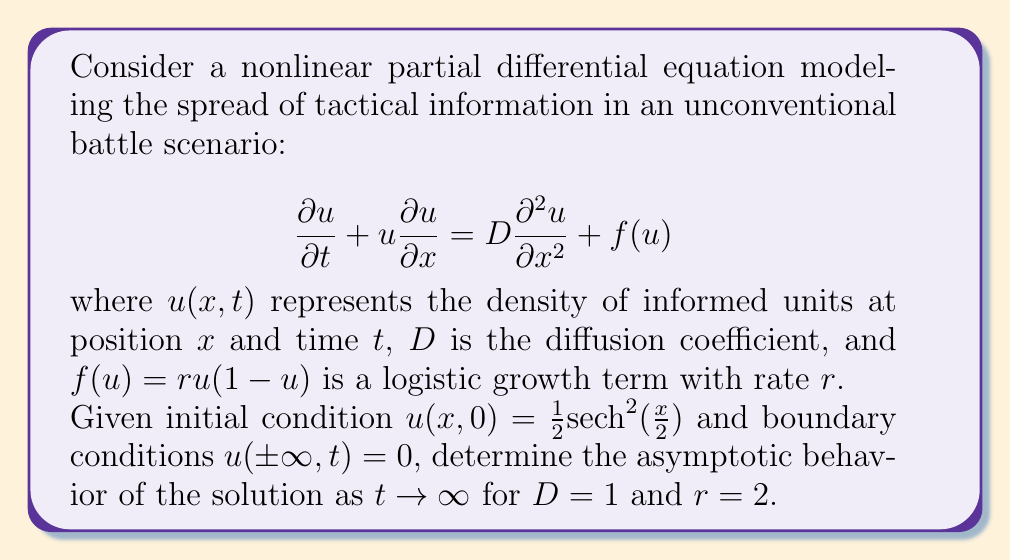Teach me how to tackle this problem. To analyze the asymptotic behavior of this nonlinear PDE, we follow these steps:

1) First, recognize that this equation is a combination of the Burgers' equation and the Fisher-KPP equation.

2) The initial condition $u(x,0) = \frac{1}{2}\text{sech}^2(\frac{x}{2})$ is a localized disturbance that decays to zero as $x \to \pm\infty$.

3) For the Fisher-KPP part ($D\frac{\partial^2 u}{\partial x^2} + ru(1-u)$), we know that:
   - There exist traveling wave solutions.
   - The minimum wave speed is $c_{min} = 2\sqrt{rD} = 2\sqrt{2} \approx 2.83$ for our parameters.

4) The Burgers' part ($u\frac{\partial u}{\partial x}$) introduces nonlinear advection, which can lead to shock formation in the absence of diffusion.

5) However, with $D > 0$, diffusion smooths out discontinuities and prevents shock formation.

6) As $t \to \infty$, the solution approaches a traveling wave profile moving with speed $c \geq c_{min}$.

7) The asymptotic shape of this traveling wave is given by:

   $$u(x,t) \approx \frac{1}{1 + e^{\frac{x-ct}{\sqrt{D}}}}$$

   where $c$ is the wave speed.

8) In this case, due to the localized initial condition and the symmetry of the problem, we expect two waves to propagate in opposite directions.

9) The speed of these waves will be the minimum speed $c_{min} = 2\sqrt{2}$, as there's no mechanism to accelerate them beyond this speed.

Therefore, as $t \to \infty$, the solution will asymptotically approach two traveling waves moving in opposite directions with speed $2\sqrt{2}$, each with the profile described in step 7.
Answer: Two opposing traveling waves with speed $2\sqrt{2}$ and profile $u(x,t) \approx \frac{1}{1 + e^{\frac{x-2\sqrt{2}t}{\sqrt{D}}}}$ 